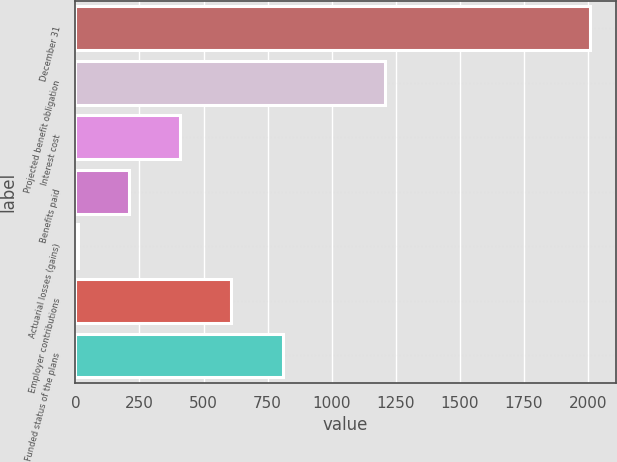Convert chart to OTSL. <chart><loc_0><loc_0><loc_500><loc_500><bar_chart><fcel>December 31<fcel>Projected benefit obligation<fcel>Interest cost<fcel>Benefits paid<fcel>Actuarial losses (gains)<fcel>Employer contributions<fcel>Funded status of the plans<nl><fcel>2009<fcel>1208.92<fcel>408.84<fcel>208.82<fcel>8.8<fcel>608.86<fcel>808.88<nl></chart> 